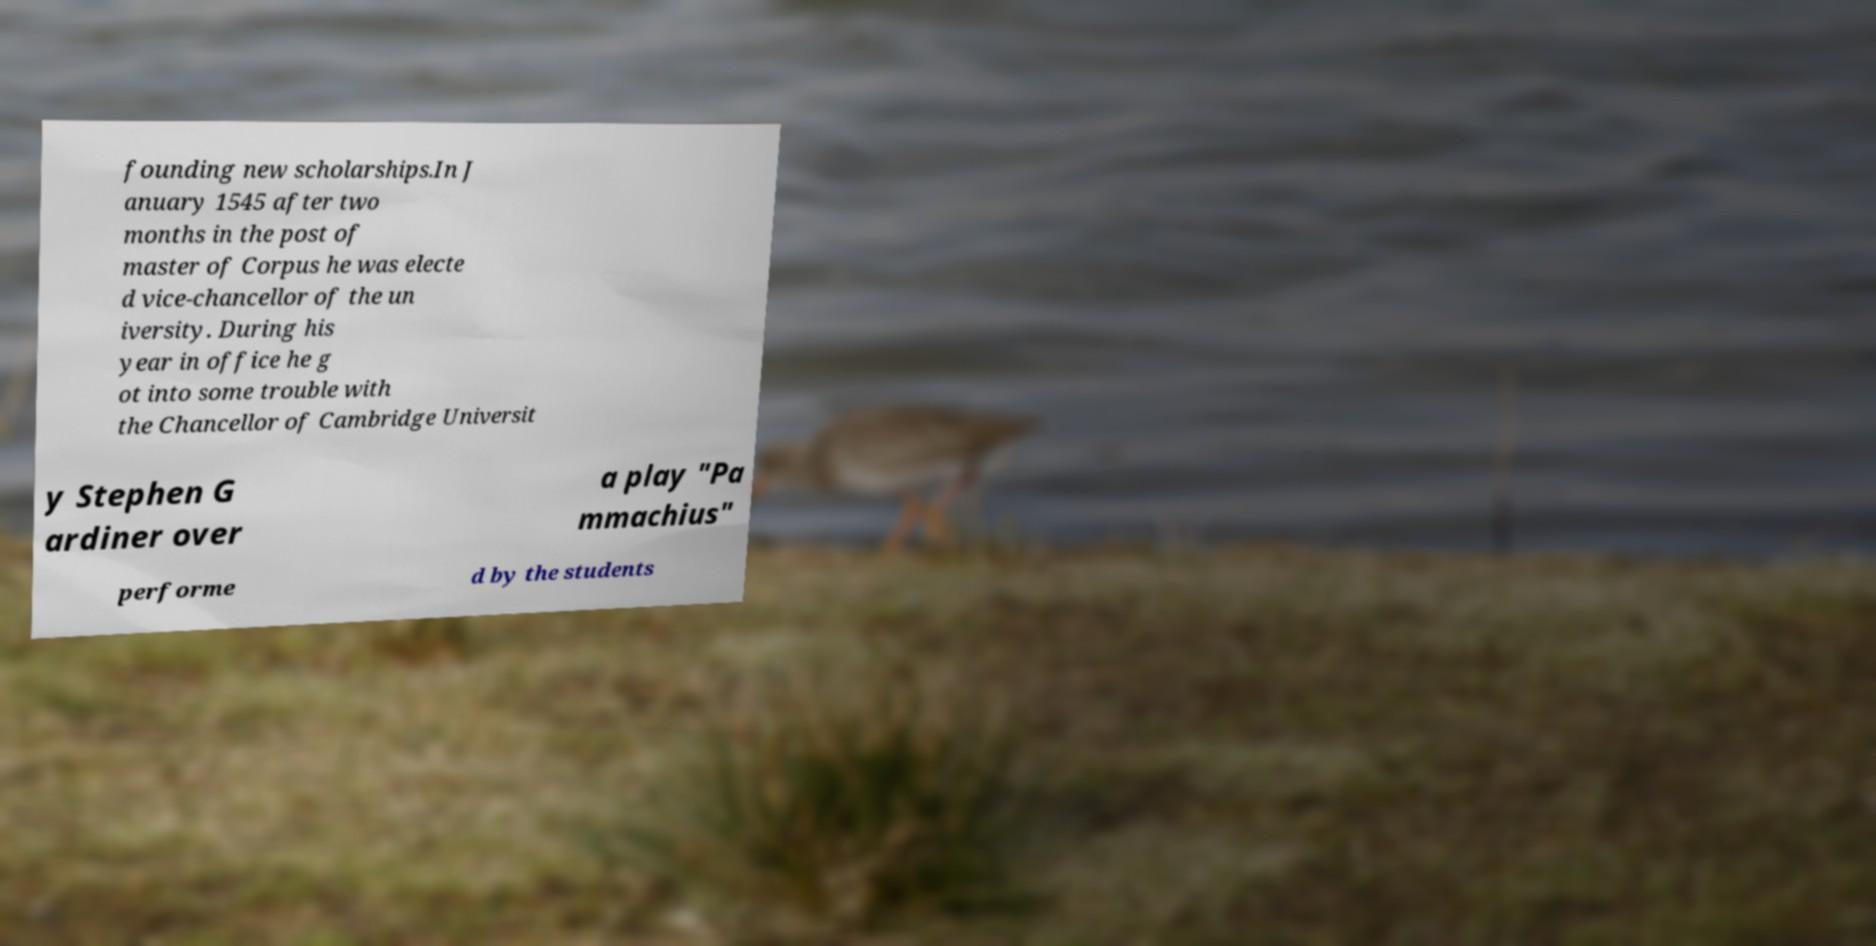Can you read and provide the text displayed in the image?This photo seems to have some interesting text. Can you extract and type it out for me? founding new scholarships.In J anuary 1545 after two months in the post of master of Corpus he was electe d vice-chancellor of the un iversity. During his year in office he g ot into some trouble with the Chancellor of Cambridge Universit y Stephen G ardiner over a play "Pa mmachius" performe d by the students 